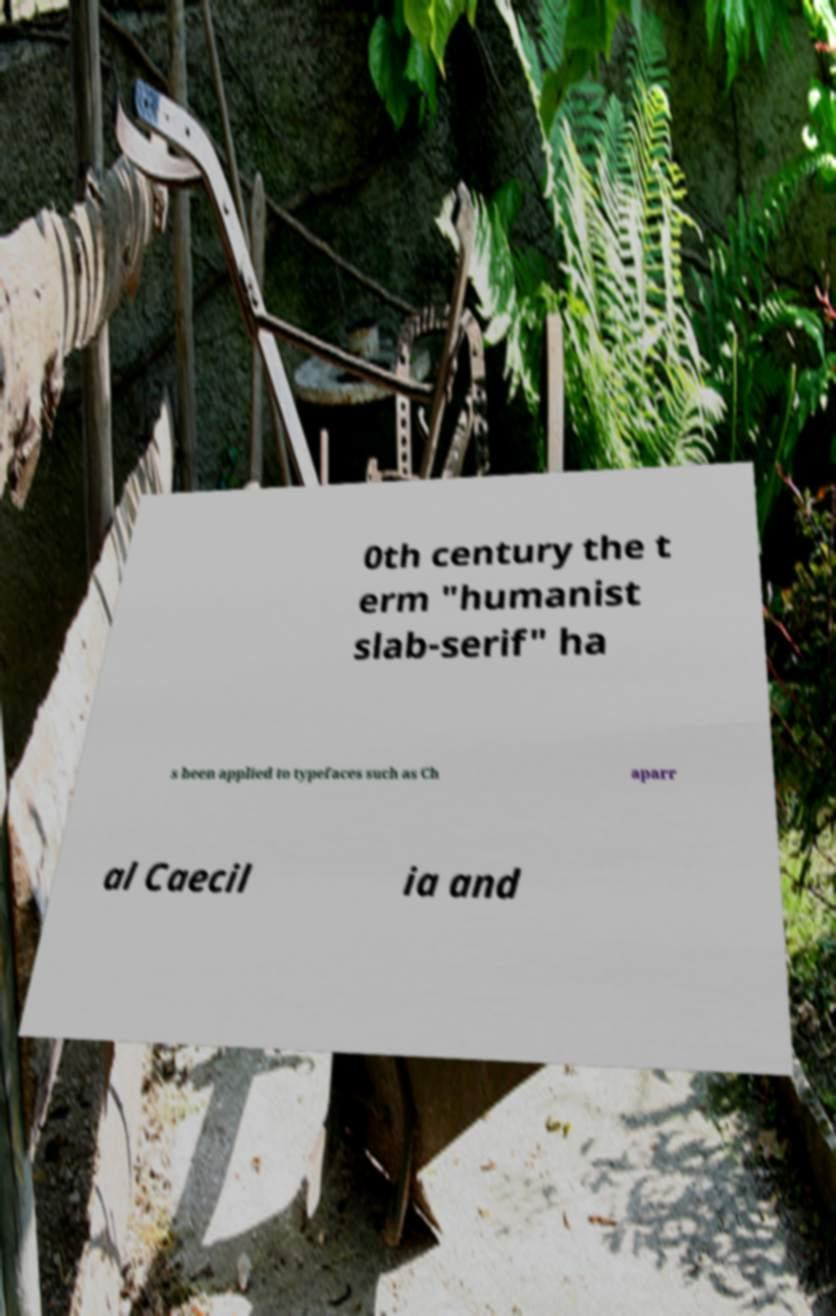Please read and relay the text visible in this image. What does it say? 0th century the t erm "humanist slab-serif" ha s been applied to typefaces such as Ch aparr al Caecil ia and 